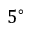<formula> <loc_0><loc_0><loc_500><loc_500>5 ^ { \circ }</formula> 